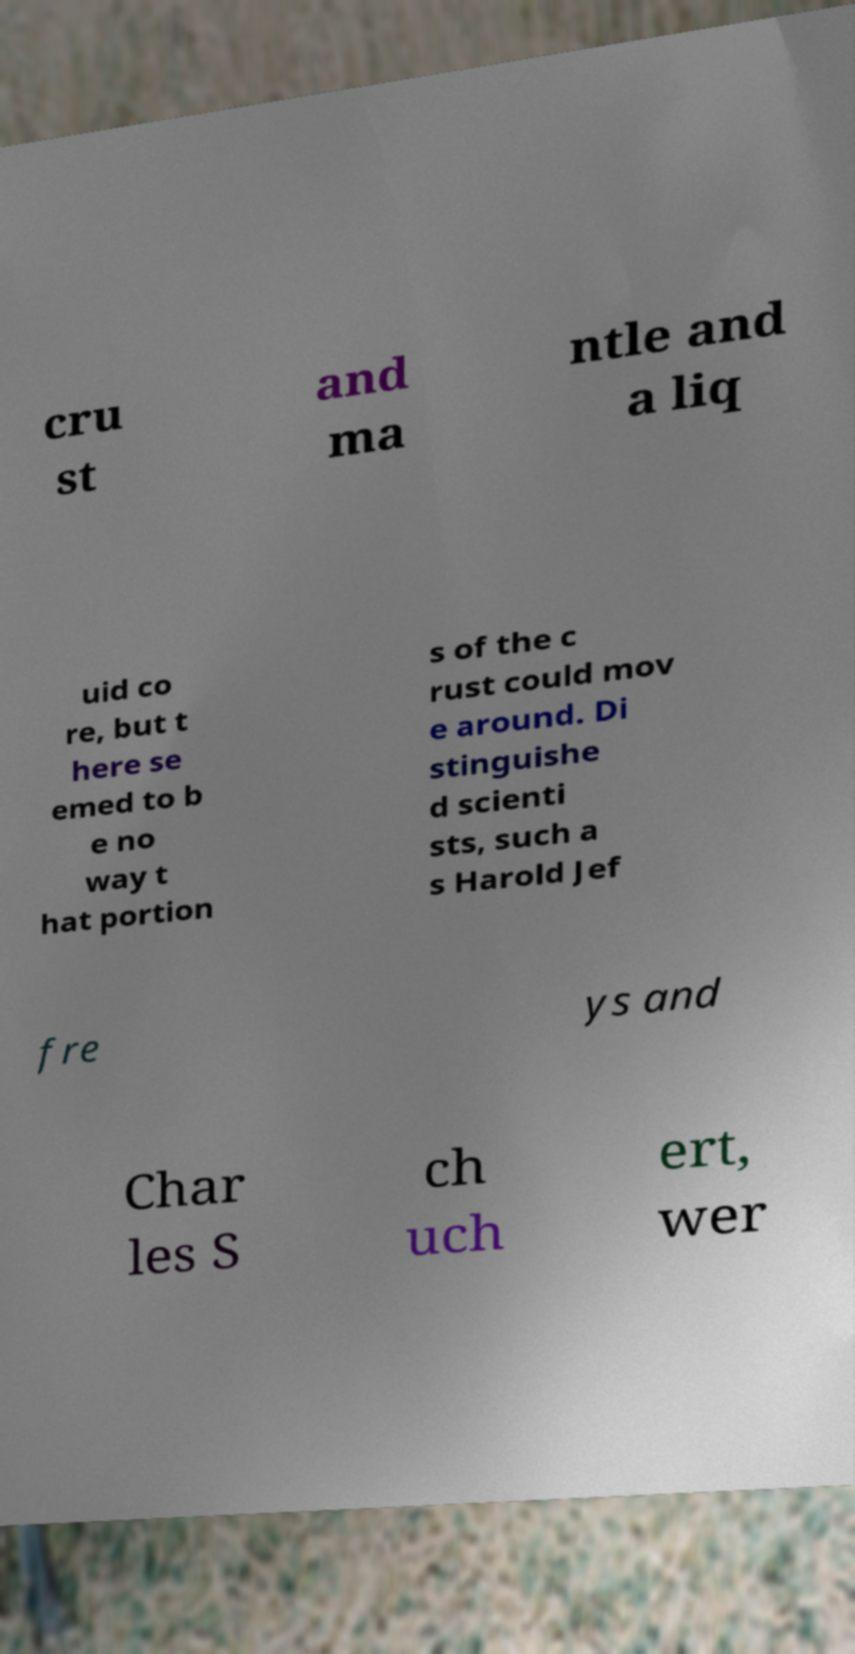Please identify and transcribe the text found in this image. cru st and ma ntle and a liq uid co re, but t here se emed to b e no way t hat portion s of the c rust could mov e around. Di stinguishe d scienti sts, such a s Harold Jef fre ys and Char les S ch uch ert, wer 